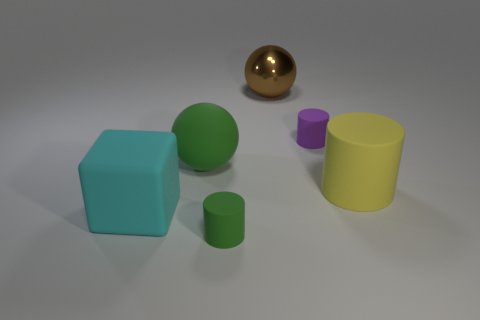Are there any objects in the image that seem out of place? All objects in the image seem appropriately placed for a composition focused on geometric shapes and contrasting materials. The golden sphere stands out due to its reflective surface but doesn't necessarily seem out of place. 